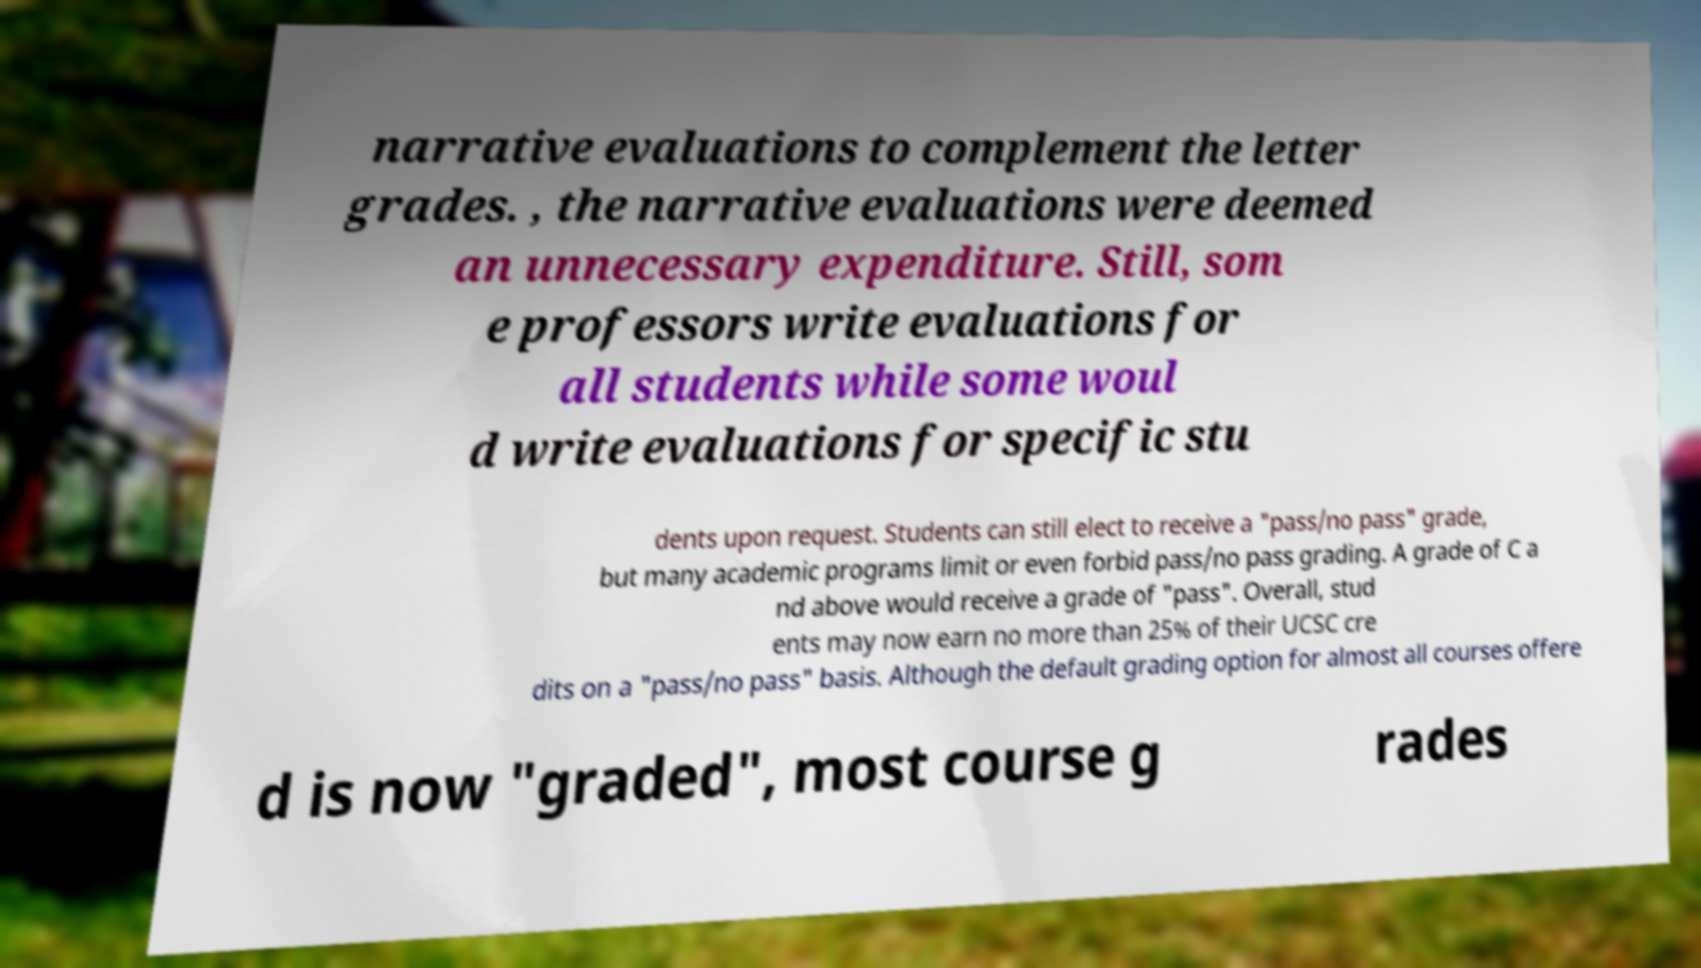I need the written content from this picture converted into text. Can you do that? narrative evaluations to complement the letter grades. , the narrative evaluations were deemed an unnecessary expenditure. Still, som e professors write evaluations for all students while some woul d write evaluations for specific stu dents upon request. Students can still elect to receive a "pass/no pass" grade, but many academic programs limit or even forbid pass/no pass grading. A grade of C a nd above would receive a grade of "pass". Overall, stud ents may now earn no more than 25% of their UCSC cre dits on a "pass/no pass" basis. Although the default grading option for almost all courses offere d is now "graded", most course g rades 